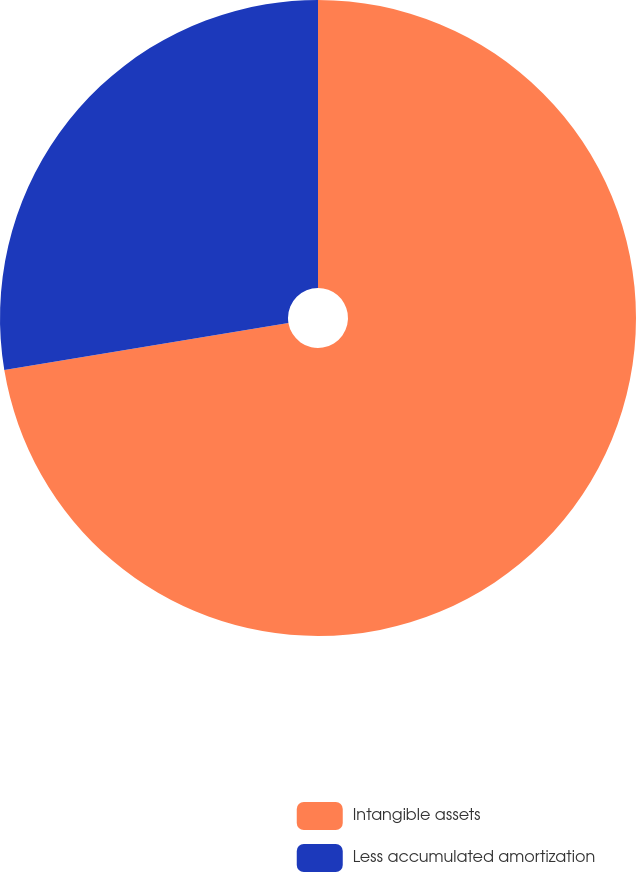Convert chart. <chart><loc_0><loc_0><loc_500><loc_500><pie_chart><fcel>Intangible assets<fcel>Less accumulated amortization<nl><fcel>72.38%<fcel>27.62%<nl></chart> 